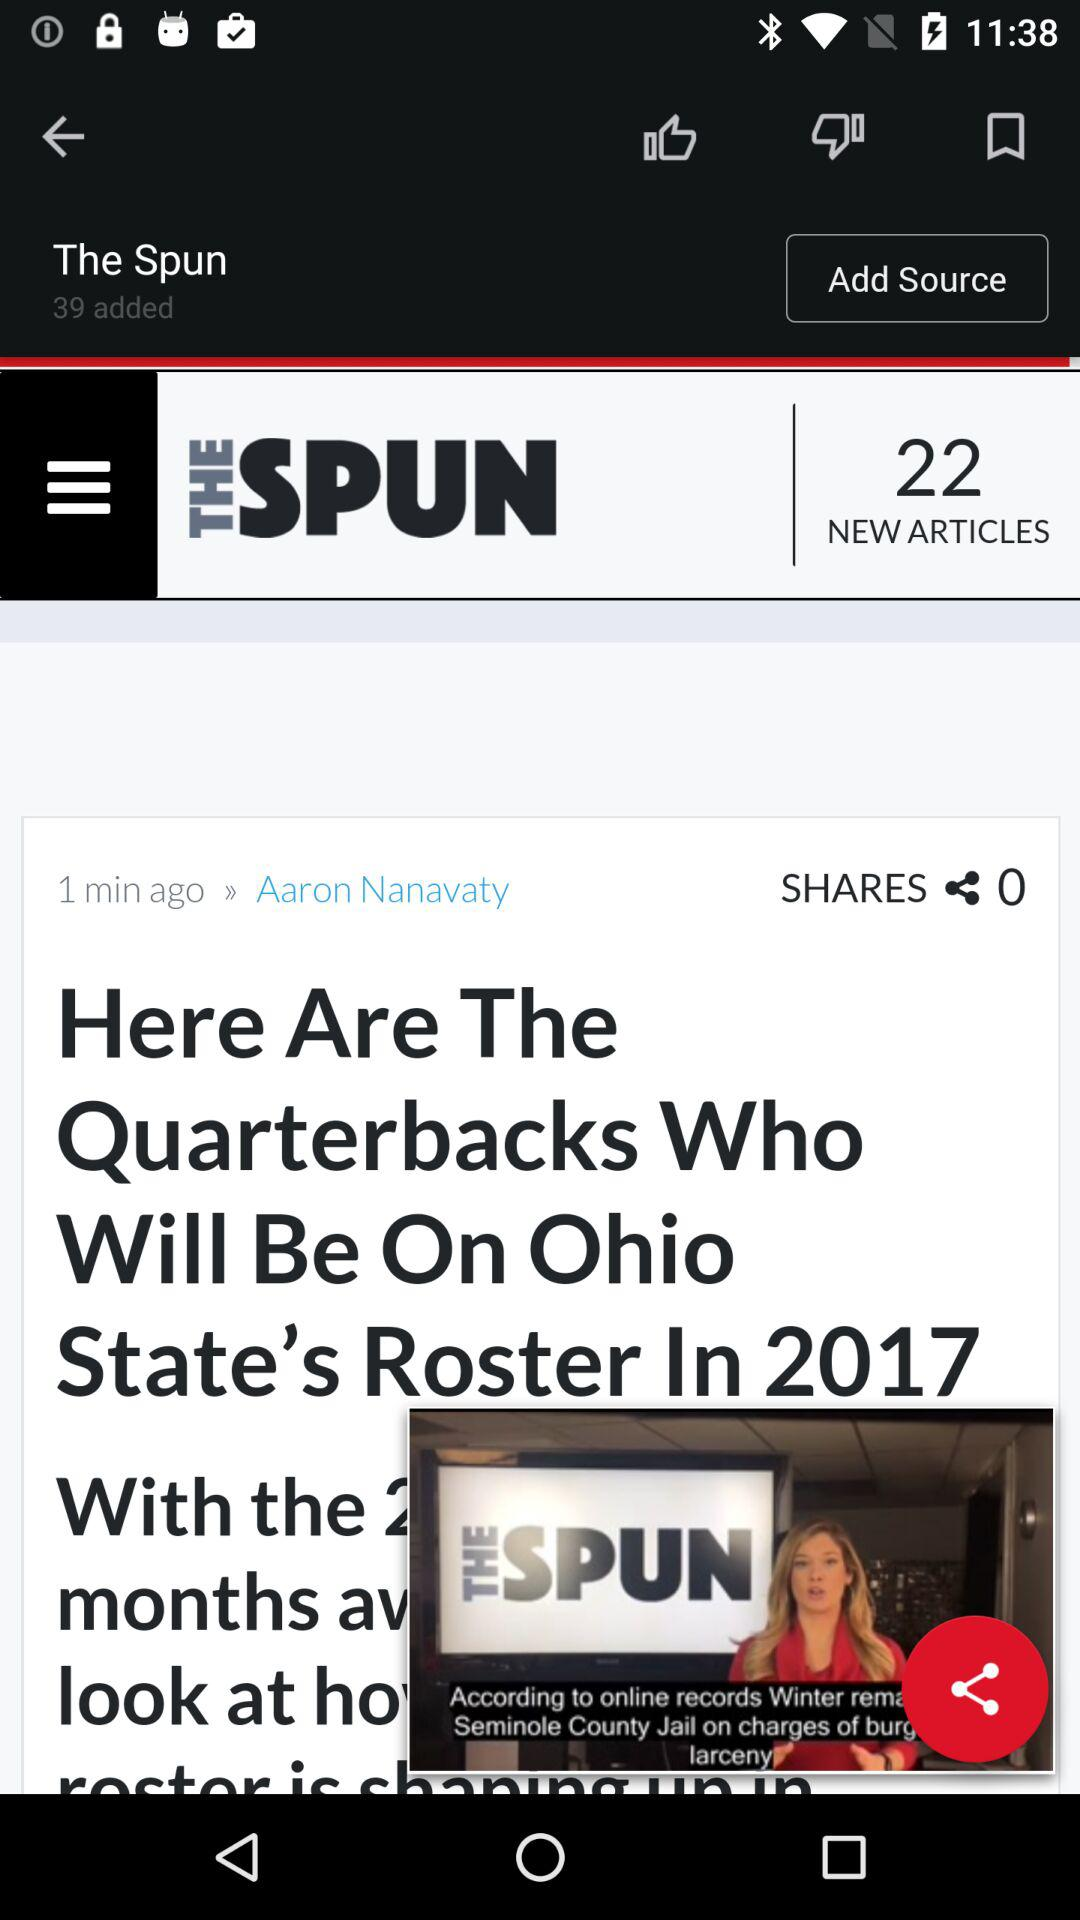When was the article published? The article was published one minute ago. 